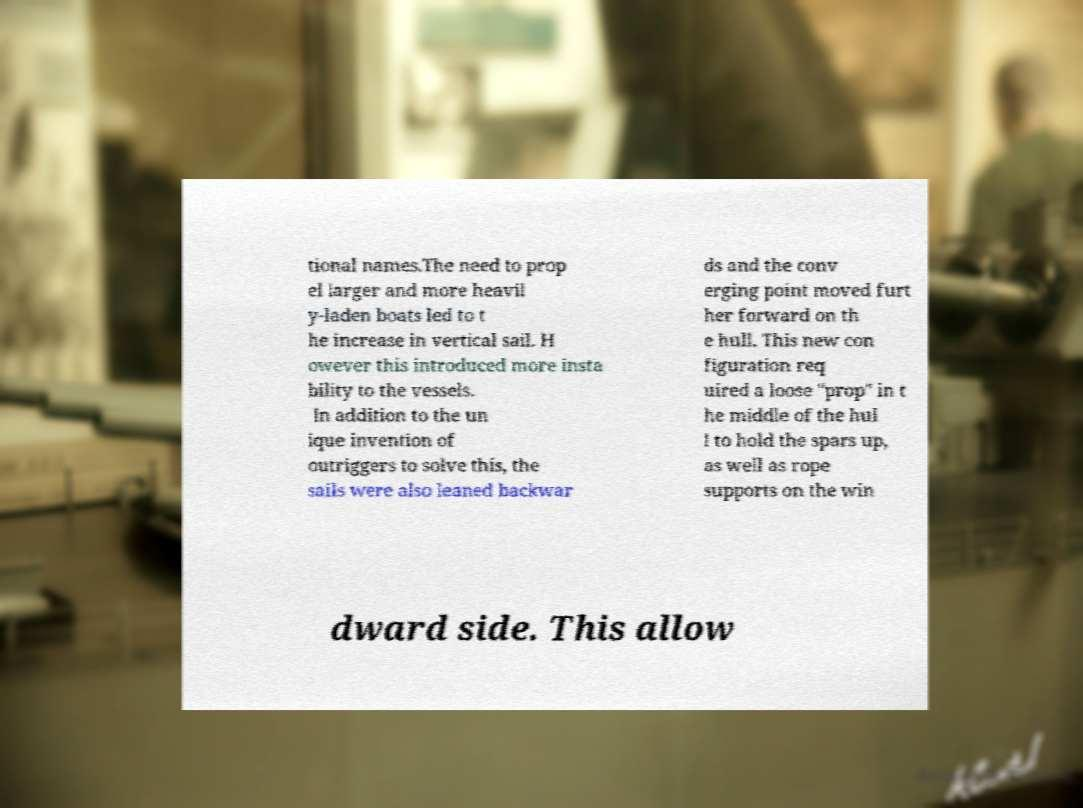Could you assist in decoding the text presented in this image and type it out clearly? tional names.The need to prop el larger and more heavil y-laden boats led to t he increase in vertical sail. H owever this introduced more insta bility to the vessels. In addition to the un ique invention of outriggers to solve this, the sails were also leaned backwar ds and the conv erging point moved furt her forward on th e hull. This new con figuration req uired a loose "prop" in t he middle of the hul l to hold the spars up, as well as rope supports on the win dward side. This allow 